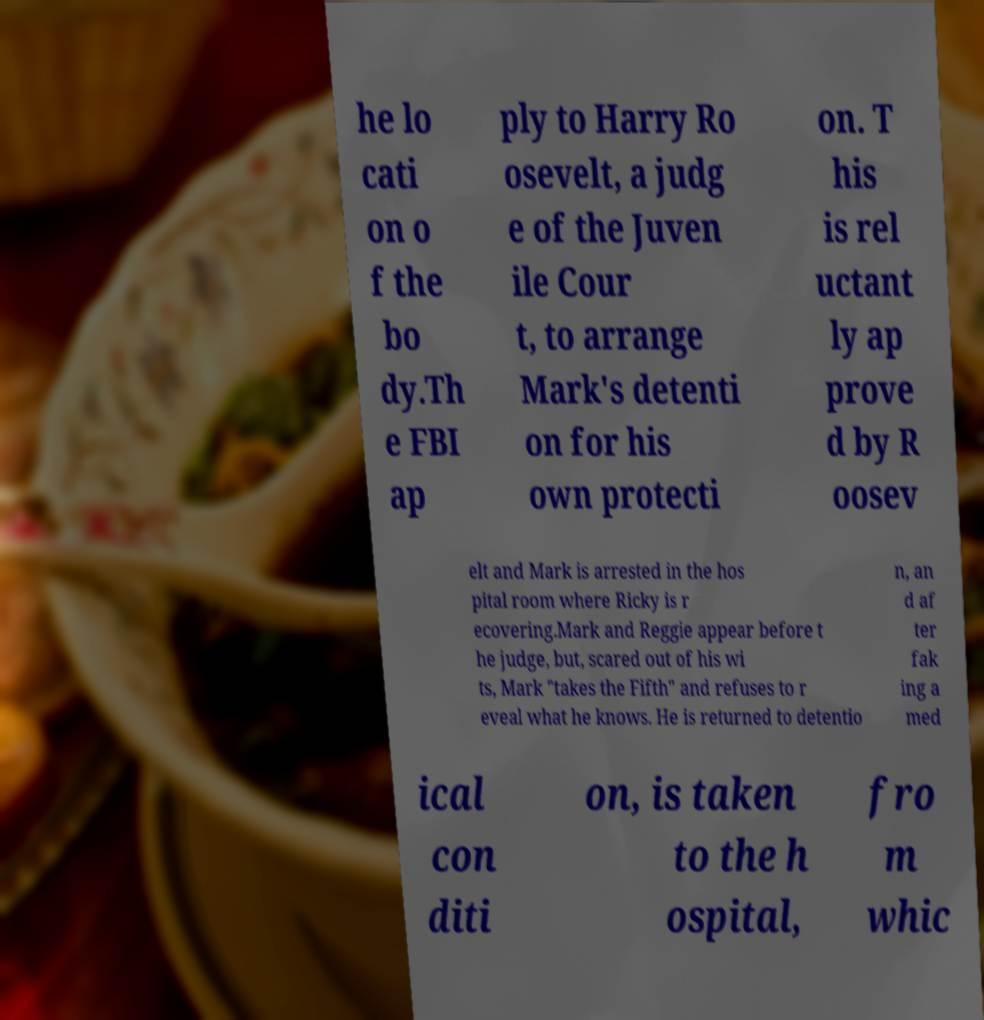I need the written content from this picture converted into text. Can you do that? he lo cati on o f the bo dy.Th e FBI ap ply to Harry Ro osevelt, a judg e of the Juven ile Cour t, to arrange Mark's detenti on for his own protecti on. T his is rel uctant ly ap prove d by R oosev elt and Mark is arrested in the hos pital room where Ricky is r ecovering.Mark and Reggie appear before t he judge, but, scared out of his wi ts, Mark "takes the Fifth" and refuses to r eveal what he knows. He is returned to detentio n, an d af ter fak ing a med ical con diti on, is taken to the h ospital, fro m whic 